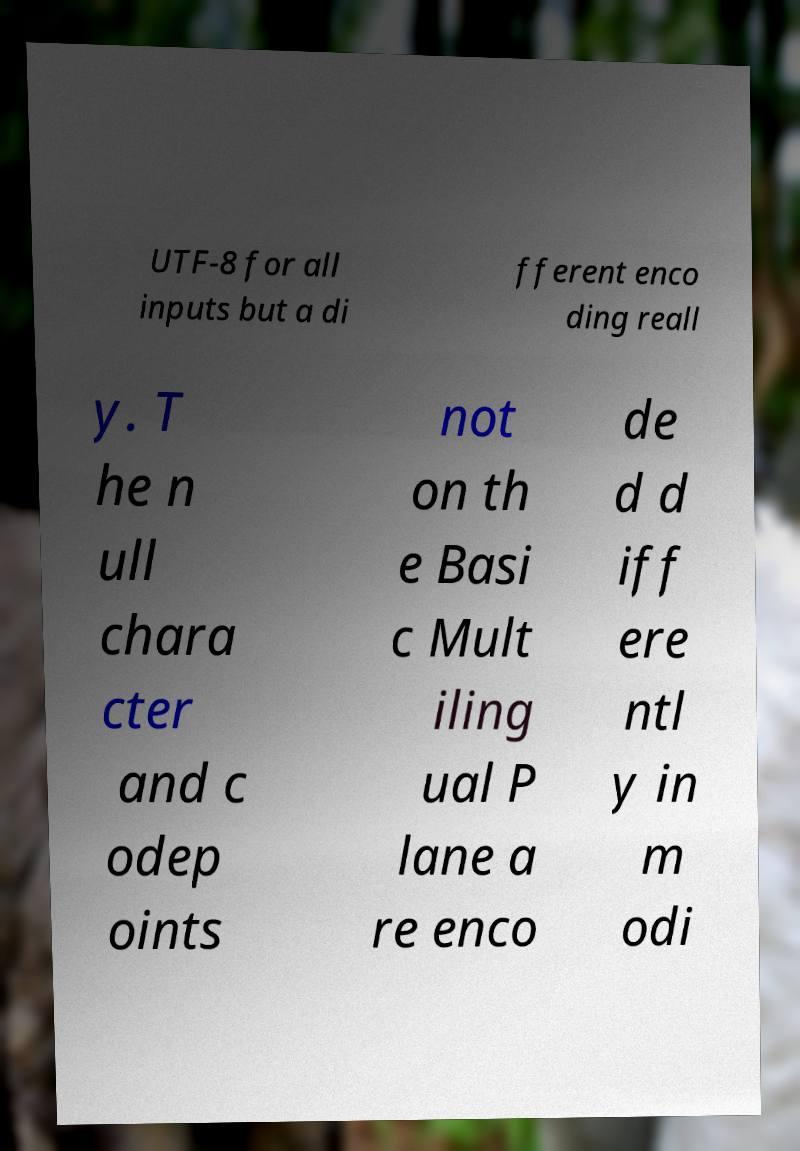Please identify and transcribe the text found in this image. UTF-8 for all inputs but a di fferent enco ding reall y. T he n ull chara cter and c odep oints not on th e Basi c Mult iling ual P lane a re enco de d d iff ere ntl y in m odi 